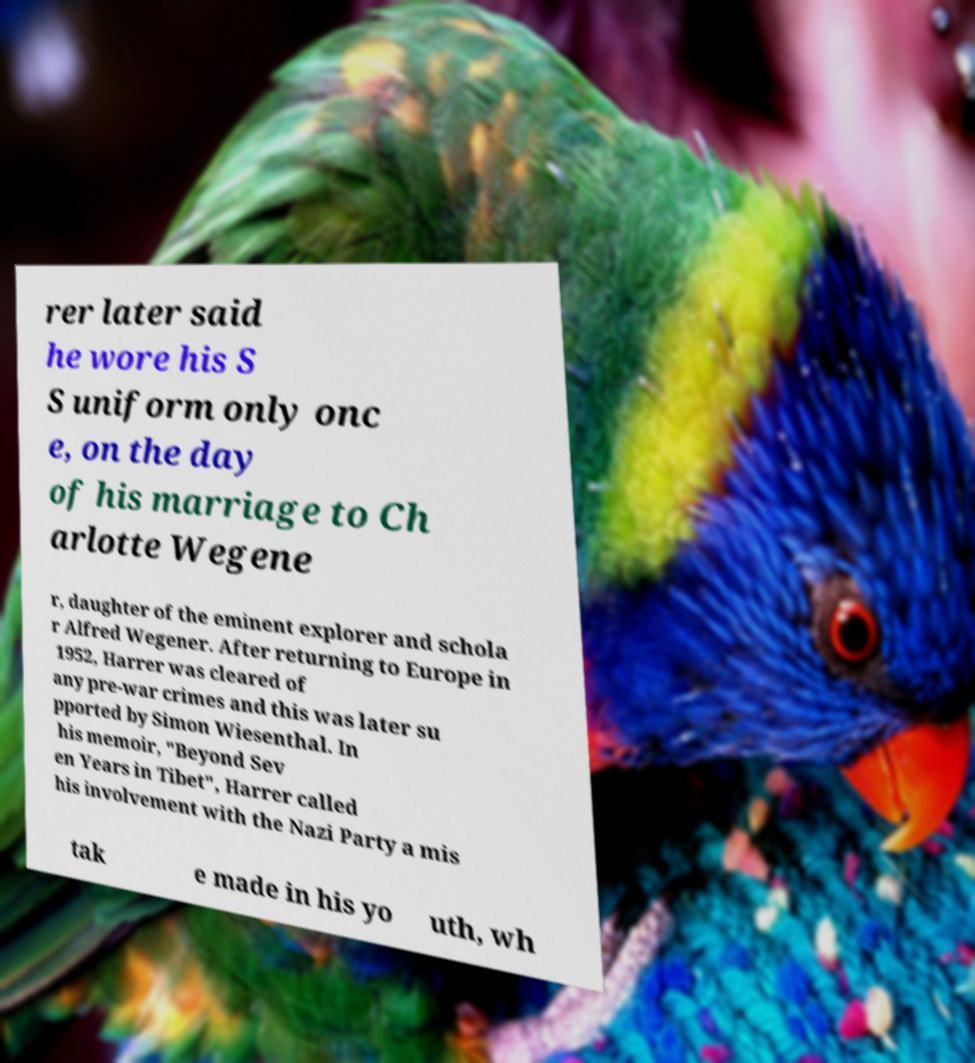What messages or text are displayed in this image? I need them in a readable, typed format. rer later said he wore his S S uniform only onc e, on the day of his marriage to Ch arlotte Wegene r, daughter of the eminent explorer and schola r Alfred Wegener. After returning to Europe in 1952, Harrer was cleared of any pre-war crimes and this was later su pported by Simon Wiesenthal. In his memoir, "Beyond Sev en Years in Tibet", Harrer called his involvement with the Nazi Party a mis tak e made in his yo uth, wh 